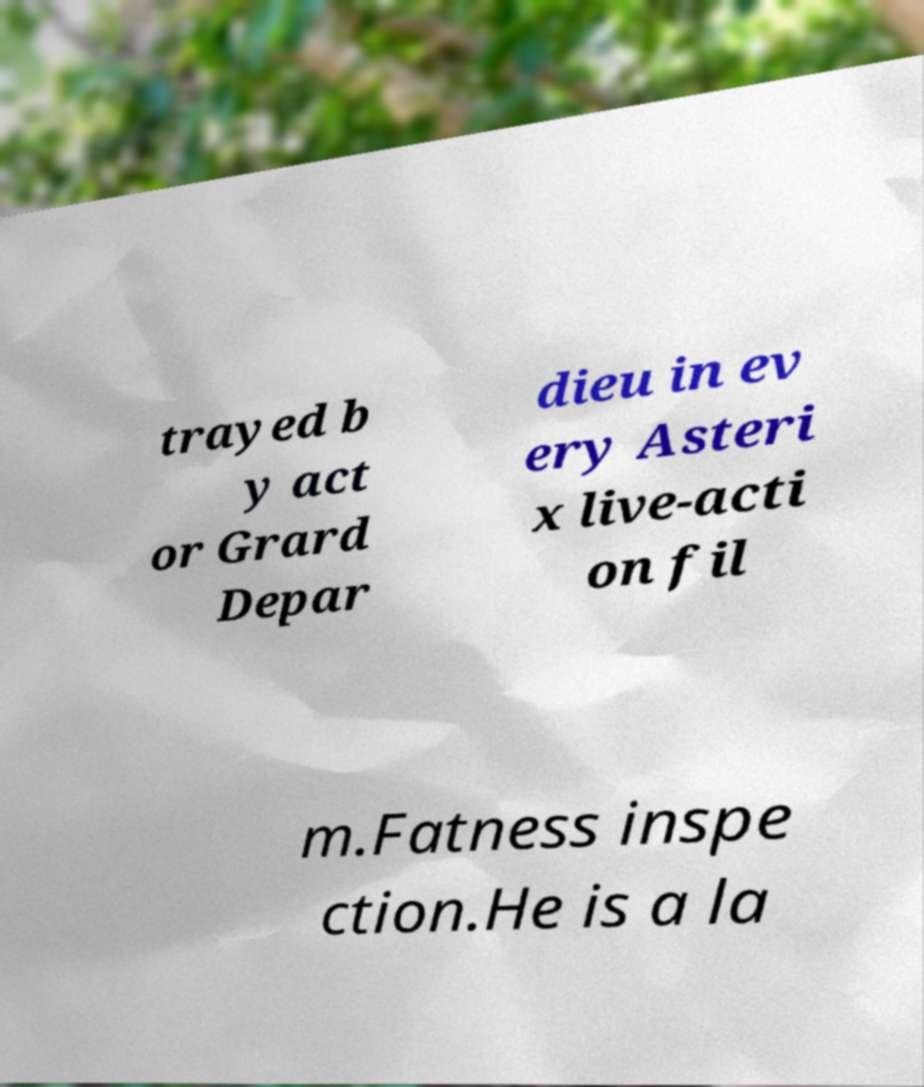For documentation purposes, I need the text within this image transcribed. Could you provide that? trayed b y act or Grard Depar dieu in ev ery Asteri x live-acti on fil m.Fatness inspe ction.He is a la 